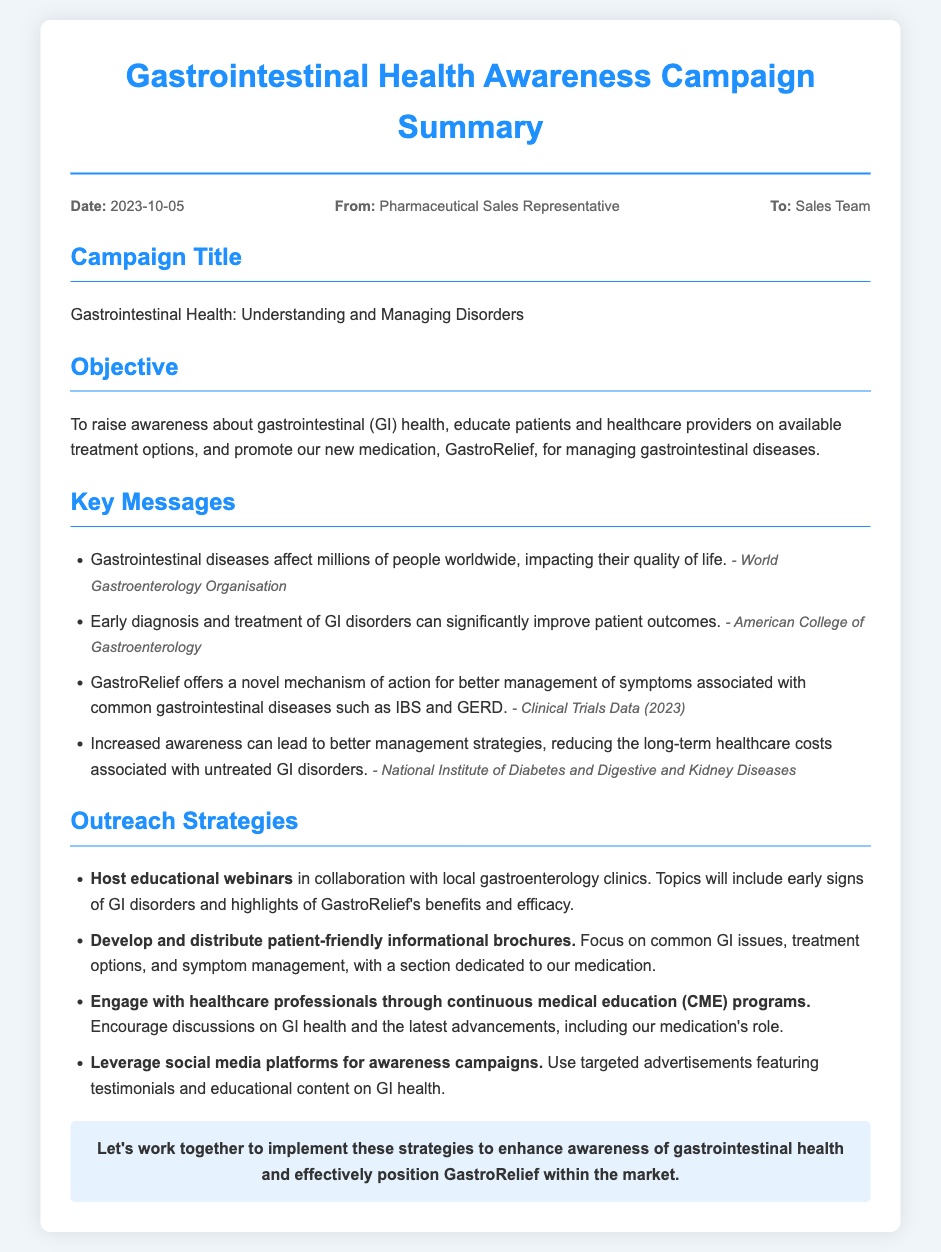What is the campaign title? The campaign title is mentioned under "Campaign Title" section of the memo.
Answer: Gastrointestinal Health: Understanding and Managing Disorders What is the date of the memo? The date is provided in the meta section of the memo.
Answer: 2023-10-05 Who is the memo addressed to? The recipient is specified in the meta section of the memo.
Answer: Sales Team What is the new medication being promoted? The medication name is mentioned under the "Objective" section.
Answer: GastroRelief What is one outreach strategy mentioned in the document? Outreach strategies are listed under the "Outreach Strategies" section, one can be selected.
Answer: Host educational webinars in collaboration with local gastroenterology clinics What is the objective of the campaign? The objective is stated in the "Objective" section of the memo.
Answer: To raise awareness about gastrointestinal (GI) health, educate patients and healthcare providers on available treatment options, and promote our new medication, GastroRelief, for managing gastrointestinal diseases How many key messages are listed in the memo? The number of key messages can be counted from the list in the "Key Messages" section.
Answer: Four What can increased awareness lead to, according to the document? The effect of increased awareness is mentioned in one of the key messages.
Answer: Better management strategies, reducing the long-term healthcare costs associated with untreated GI disorders 